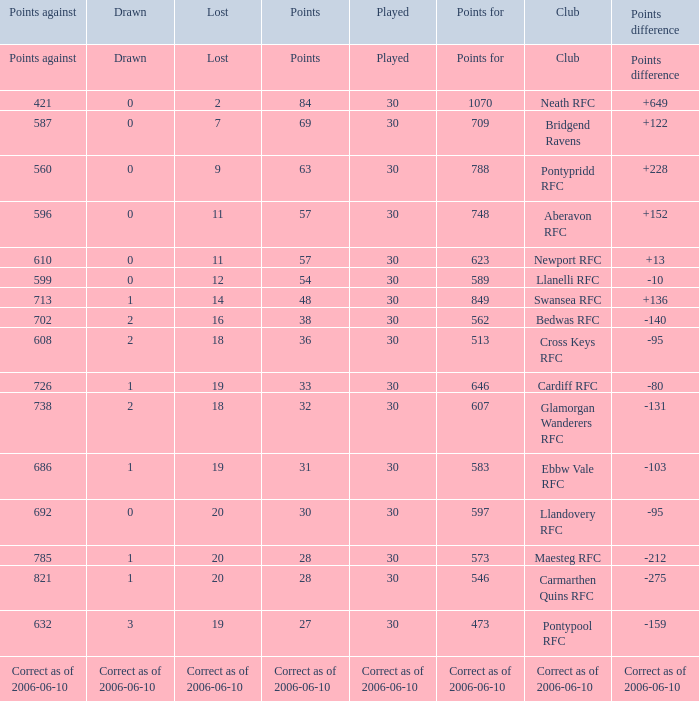What is Points Against, when Drawn is "2", and when Points Of is "32"? 738.0. 